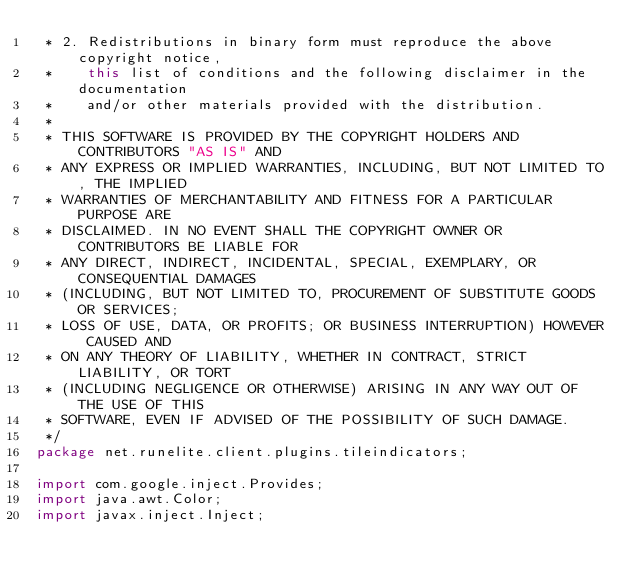Convert code to text. <code><loc_0><loc_0><loc_500><loc_500><_Java_> * 2. Redistributions in binary form must reproduce the above copyright notice,
 *    this list of conditions and the following disclaimer in the documentation
 *    and/or other materials provided with the distribution.
 *
 * THIS SOFTWARE IS PROVIDED BY THE COPYRIGHT HOLDERS AND CONTRIBUTORS "AS IS" AND
 * ANY EXPRESS OR IMPLIED WARRANTIES, INCLUDING, BUT NOT LIMITED TO, THE IMPLIED
 * WARRANTIES OF MERCHANTABILITY AND FITNESS FOR A PARTICULAR PURPOSE ARE
 * DISCLAIMED. IN NO EVENT SHALL THE COPYRIGHT OWNER OR CONTRIBUTORS BE LIABLE FOR
 * ANY DIRECT, INDIRECT, INCIDENTAL, SPECIAL, EXEMPLARY, OR CONSEQUENTIAL DAMAGES
 * (INCLUDING, BUT NOT LIMITED TO, PROCUREMENT OF SUBSTITUTE GOODS OR SERVICES;
 * LOSS OF USE, DATA, OR PROFITS; OR BUSINESS INTERRUPTION) HOWEVER CAUSED AND
 * ON ANY THEORY OF LIABILITY, WHETHER IN CONTRACT, STRICT LIABILITY, OR TORT
 * (INCLUDING NEGLIGENCE OR OTHERWISE) ARISING IN ANY WAY OUT OF THE USE OF THIS
 * SOFTWARE, EVEN IF ADVISED OF THE POSSIBILITY OF SUCH DAMAGE.
 */
package net.runelite.client.plugins.tileindicators;

import com.google.inject.Provides;
import java.awt.Color;
import javax.inject.Inject;</code> 